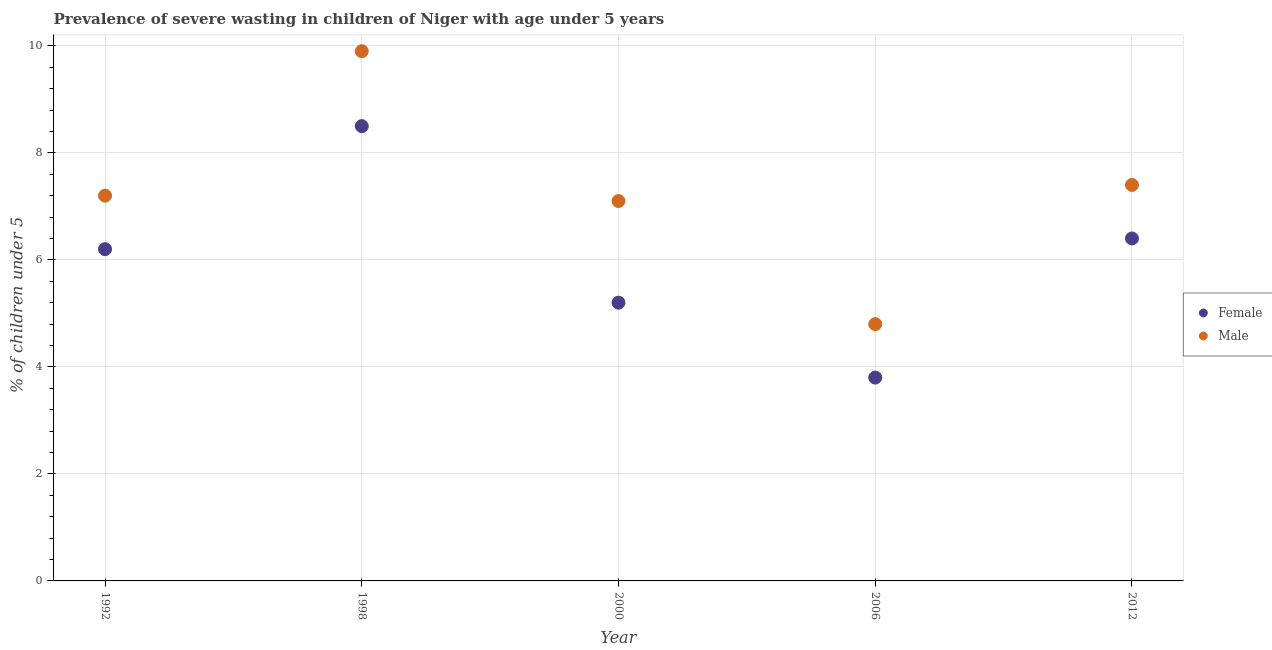Is the number of dotlines equal to the number of legend labels?
Keep it short and to the point. Yes. What is the percentage of undernourished female children in 2012?
Your answer should be very brief. 6.4. Across all years, what is the maximum percentage of undernourished male children?
Provide a succinct answer. 9.9. Across all years, what is the minimum percentage of undernourished male children?
Provide a short and direct response. 4.8. In which year was the percentage of undernourished male children maximum?
Your answer should be very brief. 1998. What is the total percentage of undernourished male children in the graph?
Provide a short and direct response. 36.4. What is the difference between the percentage of undernourished male children in 2000 and that in 2012?
Ensure brevity in your answer.  -0.3. What is the difference between the percentage of undernourished male children in 2000 and the percentage of undernourished female children in 1992?
Your answer should be very brief. 0.9. What is the average percentage of undernourished female children per year?
Ensure brevity in your answer.  6.02. In the year 2006, what is the difference between the percentage of undernourished male children and percentage of undernourished female children?
Ensure brevity in your answer.  1. In how many years, is the percentage of undernourished male children greater than 7.6 %?
Offer a terse response. 1. What is the ratio of the percentage of undernourished male children in 1992 to that in 2000?
Keep it short and to the point. 1.01. Is the difference between the percentage of undernourished female children in 2006 and 2012 greater than the difference between the percentage of undernourished male children in 2006 and 2012?
Give a very brief answer. No. What is the difference between the highest and the second highest percentage of undernourished male children?
Your answer should be compact. 2.5. What is the difference between the highest and the lowest percentage of undernourished male children?
Provide a succinct answer. 5.1. In how many years, is the percentage of undernourished female children greater than the average percentage of undernourished female children taken over all years?
Your answer should be compact. 3. Is the sum of the percentage of undernourished female children in 1992 and 2000 greater than the maximum percentage of undernourished male children across all years?
Provide a short and direct response. Yes. Does the percentage of undernourished female children monotonically increase over the years?
Offer a terse response. No. Is the percentage of undernourished female children strictly greater than the percentage of undernourished male children over the years?
Make the answer very short. No. Is the percentage of undernourished female children strictly less than the percentage of undernourished male children over the years?
Your answer should be very brief. Yes. What is the difference between two consecutive major ticks on the Y-axis?
Make the answer very short. 2. Are the values on the major ticks of Y-axis written in scientific E-notation?
Provide a succinct answer. No. Does the graph contain any zero values?
Provide a short and direct response. No. Does the graph contain grids?
Your answer should be compact. Yes. Where does the legend appear in the graph?
Keep it short and to the point. Center right. How are the legend labels stacked?
Ensure brevity in your answer.  Vertical. What is the title of the graph?
Your answer should be very brief. Prevalence of severe wasting in children of Niger with age under 5 years. Does "From production" appear as one of the legend labels in the graph?
Offer a very short reply. No. What is the label or title of the Y-axis?
Keep it short and to the point.  % of children under 5. What is the  % of children under 5 of Female in 1992?
Give a very brief answer. 6.2. What is the  % of children under 5 in Male in 1992?
Provide a short and direct response. 7.2. What is the  % of children under 5 of Female in 1998?
Your answer should be compact. 8.5. What is the  % of children under 5 in Male in 1998?
Offer a terse response. 9.9. What is the  % of children under 5 in Female in 2000?
Ensure brevity in your answer.  5.2. What is the  % of children under 5 of Male in 2000?
Offer a very short reply. 7.1. What is the  % of children under 5 of Female in 2006?
Give a very brief answer. 3.8. What is the  % of children under 5 in Male in 2006?
Offer a very short reply. 4.8. What is the  % of children under 5 in Female in 2012?
Provide a short and direct response. 6.4. What is the  % of children under 5 in Male in 2012?
Provide a succinct answer. 7.4. Across all years, what is the maximum  % of children under 5 of Female?
Provide a short and direct response. 8.5. Across all years, what is the maximum  % of children under 5 of Male?
Your response must be concise. 9.9. Across all years, what is the minimum  % of children under 5 of Female?
Your response must be concise. 3.8. Across all years, what is the minimum  % of children under 5 of Male?
Provide a succinct answer. 4.8. What is the total  % of children under 5 in Female in the graph?
Your answer should be compact. 30.1. What is the total  % of children under 5 in Male in the graph?
Ensure brevity in your answer.  36.4. What is the difference between the  % of children under 5 of Female in 1992 and that in 1998?
Keep it short and to the point. -2.3. What is the difference between the  % of children under 5 of Female in 1992 and that in 2006?
Provide a short and direct response. 2.4. What is the difference between the  % of children under 5 in Male in 1992 and that in 2006?
Offer a terse response. 2.4. What is the difference between the  % of children under 5 of Female in 1992 and that in 2012?
Your answer should be compact. -0.2. What is the difference between the  % of children under 5 in Male in 1998 and that in 2000?
Offer a terse response. 2.8. What is the difference between the  % of children under 5 in Male in 1998 and that in 2012?
Keep it short and to the point. 2.5. What is the difference between the  % of children under 5 of Male in 2000 and that in 2006?
Make the answer very short. 2.3. What is the difference between the  % of children under 5 in Male in 2000 and that in 2012?
Give a very brief answer. -0.3. What is the difference between the  % of children under 5 of Female in 1992 and the  % of children under 5 of Male in 1998?
Keep it short and to the point. -3.7. What is the difference between the  % of children under 5 of Female in 1992 and the  % of children under 5 of Male in 2006?
Give a very brief answer. 1.4. What is the difference between the  % of children under 5 in Female in 1992 and the  % of children under 5 in Male in 2012?
Make the answer very short. -1.2. What is the difference between the  % of children under 5 of Female in 1998 and the  % of children under 5 of Male in 2012?
Your answer should be compact. 1.1. What is the difference between the  % of children under 5 of Female in 2000 and the  % of children under 5 of Male in 2012?
Your answer should be compact. -2.2. What is the average  % of children under 5 in Female per year?
Offer a very short reply. 6.02. What is the average  % of children under 5 of Male per year?
Provide a succinct answer. 7.28. In the year 2000, what is the difference between the  % of children under 5 in Female and  % of children under 5 in Male?
Offer a terse response. -1.9. In the year 2006, what is the difference between the  % of children under 5 of Female and  % of children under 5 of Male?
Keep it short and to the point. -1. What is the ratio of the  % of children under 5 of Female in 1992 to that in 1998?
Provide a short and direct response. 0.73. What is the ratio of the  % of children under 5 of Male in 1992 to that in 1998?
Offer a terse response. 0.73. What is the ratio of the  % of children under 5 in Female in 1992 to that in 2000?
Your response must be concise. 1.19. What is the ratio of the  % of children under 5 of Male in 1992 to that in 2000?
Make the answer very short. 1.01. What is the ratio of the  % of children under 5 of Female in 1992 to that in 2006?
Give a very brief answer. 1.63. What is the ratio of the  % of children under 5 in Female in 1992 to that in 2012?
Offer a very short reply. 0.97. What is the ratio of the  % of children under 5 in Male in 1992 to that in 2012?
Keep it short and to the point. 0.97. What is the ratio of the  % of children under 5 of Female in 1998 to that in 2000?
Offer a very short reply. 1.63. What is the ratio of the  % of children under 5 of Male in 1998 to that in 2000?
Your response must be concise. 1.39. What is the ratio of the  % of children under 5 of Female in 1998 to that in 2006?
Your response must be concise. 2.24. What is the ratio of the  % of children under 5 of Male in 1998 to that in 2006?
Offer a very short reply. 2.06. What is the ratio of the  % of children under 5 of Female in 1998 to that in 2012?
Your answer should be compact. 1.33. What is the ratio of the  % of children under 5 in Male in 1998 to that in 2012?
Provide a short and direct response. 1.34. What is the ratio of the  % of children under 5 in Female in 2000 to that in 2006?
Your answer should be very brief. 1.37. What is the ratio of the  % of children under 5 of Male in 2000 to that in 2006?
Provide a succinct answer. 1.48. What is the ratio of the  % of children under 5 of Female in 2000 to that in 2012?
Offer a terse response. 0.81. What is the ratio of the  % of children under 5 of Male in 2000 to that in 2012?
Offer a very short reply. 0.96. What is the ratio of the  % of children under 5 in Female in 2006 to that in 2012?
Make the answer very short. 0.59. What is the ratio of the  % of children under 5 in Male in 2006 to that in 2012?
Offer a terse response. 0.65. What is the difference between the highest and the second highest  % of children under 5 of Female?
Offer a very short reply. 2.1. What is the difference between the highest and the lowest  % of children under 5 in Female?
Keep it short and to the point. 4.7. 